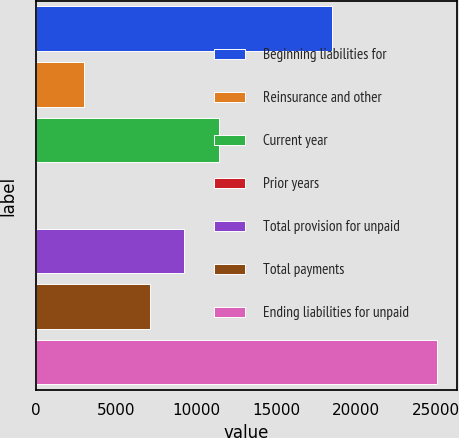Convert chart to OTSL. <chart><loc_0><loc_0><loc_500><loc_500><bar_chart><fcel>Beginning liabilities for<fcel>Reinsurance and other<fcel>Current year<fcel>Prior years<fcel>Total provision for unpaid<fcel>Total payments<fcel>Ending liabilities for unpaid<nl><fcel>18517<fcel>3033<fcel>11440.4<fcel>4<fcel>9269.2<fcel>7098<fcel>25030.6<nl></chart> 